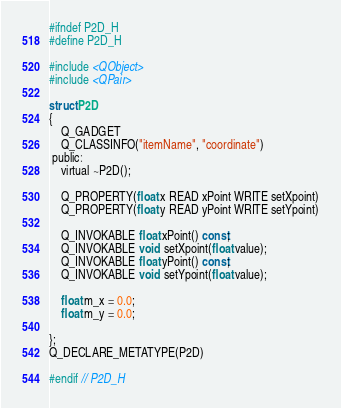Convert code to text. <code><loc_0><loc_0><loc_500><loc_500><_C_>#ifndef P2D_H
#define P2D_H

#include <QObject>
#include <QPair>

struct P2D
{
    Q_GADGET
    Q_CLASSINFO("itemName", "coordinate")
 public:
    virtual ~P2D();

    Q_PROPERTY(float x READ xPoint WRITE setXpoint)
    Q_PROPERTY(float y READ yPoint WRITE setYpoint)

    Q_INVOKABLE float xPoint() const;
    Q_INVOKABLE void  setXpoint(float value);
    Q_INVOKABLE float yPoint() const;
    Q_INVOKABLE void  setYpoint(float value);

    float m_x = 0.0;
    float m_y = 0.0;

};
Q_DECLARE_METATYPE(P2D)

#endif // P2D_H
</code> 